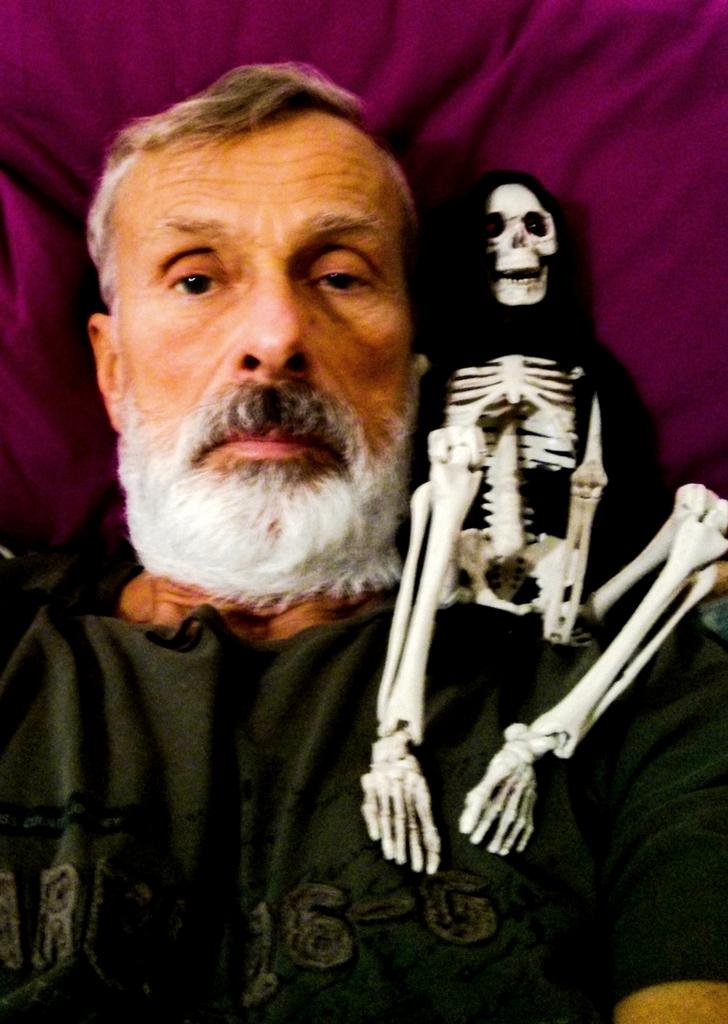What is the main subject of the image? The main subject of the image is a man. What other object or figure is present in the image? There is a skeleton in the image. What type of material is visible in the image? There is cloth in the image. Can you tell me how many snails are crawling on the man's shoulder in the image? There are no snails present in the image. What type of credit card is the man holding in the image? There is no credit card visible in the image. 